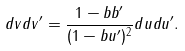<formula> <loc_0><loc_0><loc_500><loc_500>d v d v ^ { \prime } = \frac { 1 - b b ^ { \prime } } { ( 1 - b u ^ { \prime } ) ^ { 2 } } d u d u ^ { \prime } .</formula> 